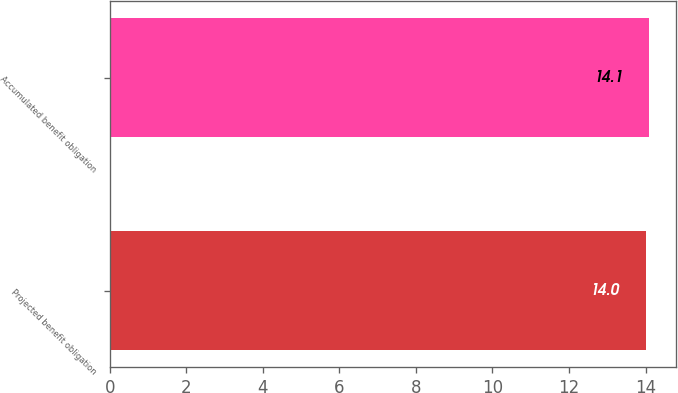Convert chart to OTSL. <chart><loc_0><loc_0><loc_500><loc_500><bar_chart><fcel>Projected benefit obligation<fcel>Accumulated benefit obligation<nl><fcel>14<fcel>14.1<nl></chart> 